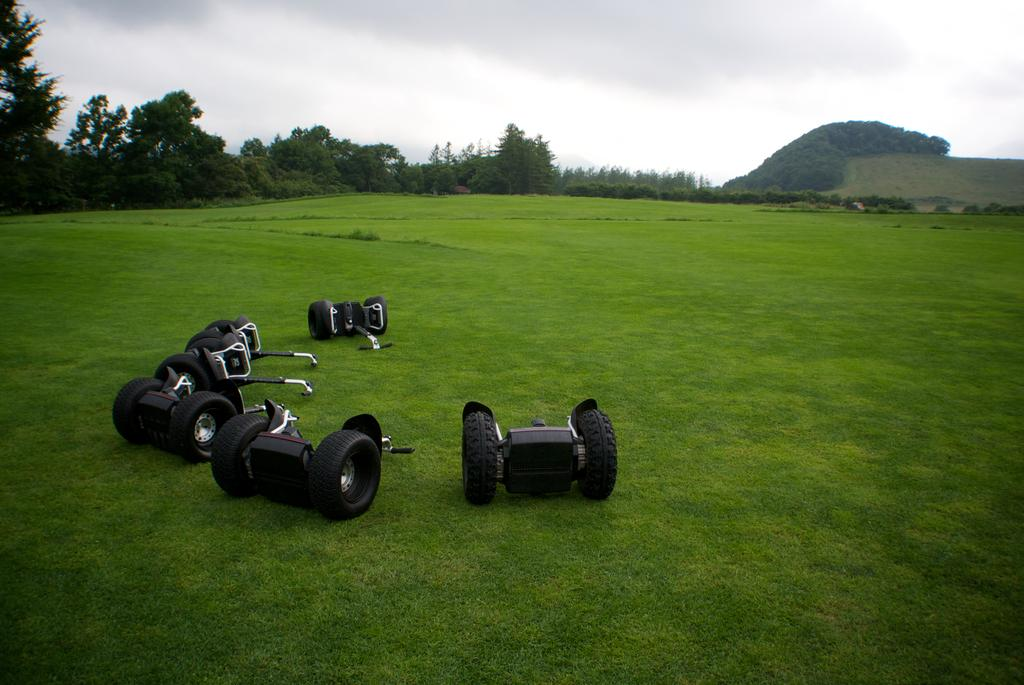What type of vegetation covers the land in the image? The land in the image is covered with grass. What can be seen on top of the grass? There are black color objects on the grass. How would you describe the sky in the image? The sky is full of clouds. What can be seen in the distance in the image? Trees are present in the background of the image. What arithmetic problem is being solved by the sheep in the image? There are no sheep present in the image, and therefore no arithmetic problem can be observed. Who is the partner of the person in the image? There is no person present in the image, so it is impossible to determine who their partner might be. 